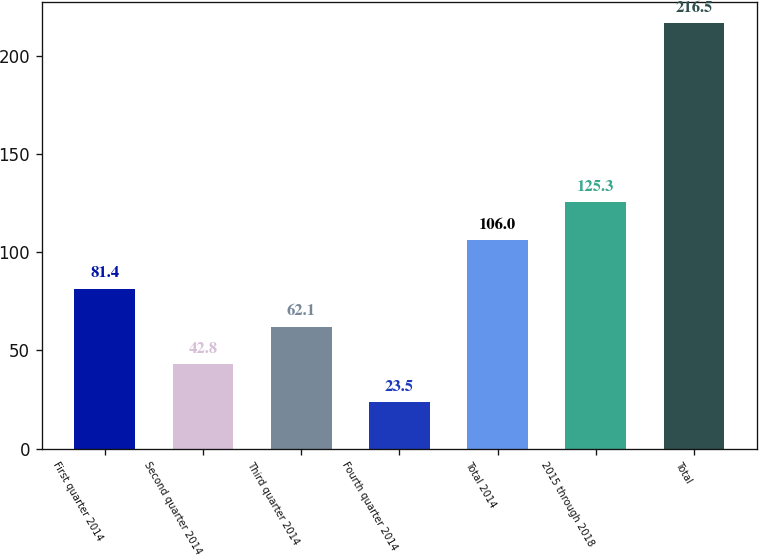Convert chart. <chart><loc_0><loc_0><loc_500><loc_500><bar_chart><fcel>First quarter 2014<fcel>Second quarter 2014<fcel>Third quarter 2014<fcel>Fourth quarter 2014<fcel>Total 2014<fcel>2015 through 2018<fcel>Total<nl><fcel>81.4<fcel>42.8<fcel>62.1<fcel>23.5<fcel>106<fcel>125.3<fcel>216.5<nl></chart> 